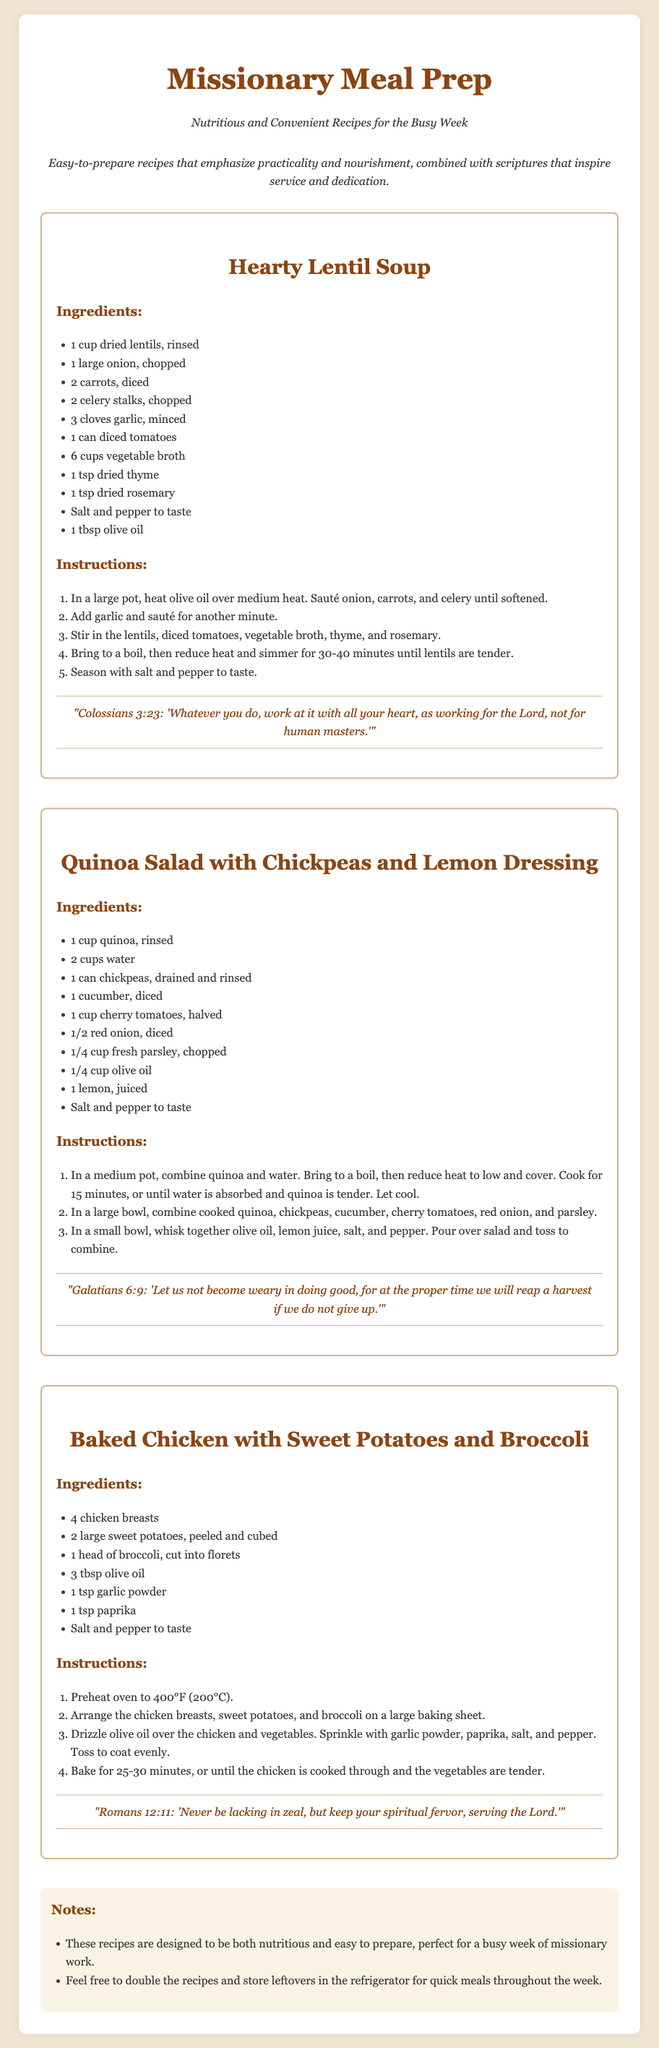What is the title of the document? The title of the document is presented prominently at the top of the card.
Answer: Missionary Meal Prep How many recipes are included in the document? The document includes three distinct recipes.
Answer: Three What is the main ingredient of the Hearty Lentil Soup? The main ingredient is the first item listed in the ingredients section for the Hearty Lentil Soup.
Answer: Dried lentils What scripture accompanies the Baked Chicken recipe? The scripture is quoted below the recipe and relates to serving the Lord.
Answer: Romans 12:11 What is the cooking time for quinoa in the Quinoa Salad recipe? The cooking time is noted in the instructions section for that specific recipe.
Answer: 15 minutes What vegetable is included in the Baked Chicken recipe? The vegetable is listed in the ingredients and is one of the sides for the meal.
Answer: Broccoli What is emphasized in the subtitle of the document? The subtitle conveys the primary goal or focus of the recipes provided.
Answer: Practicality and nourishment What should you do with leftovers according to the notes? The notes provide guidance on storing food for convenience.
Answer: Store leftovers in the refrigerator 